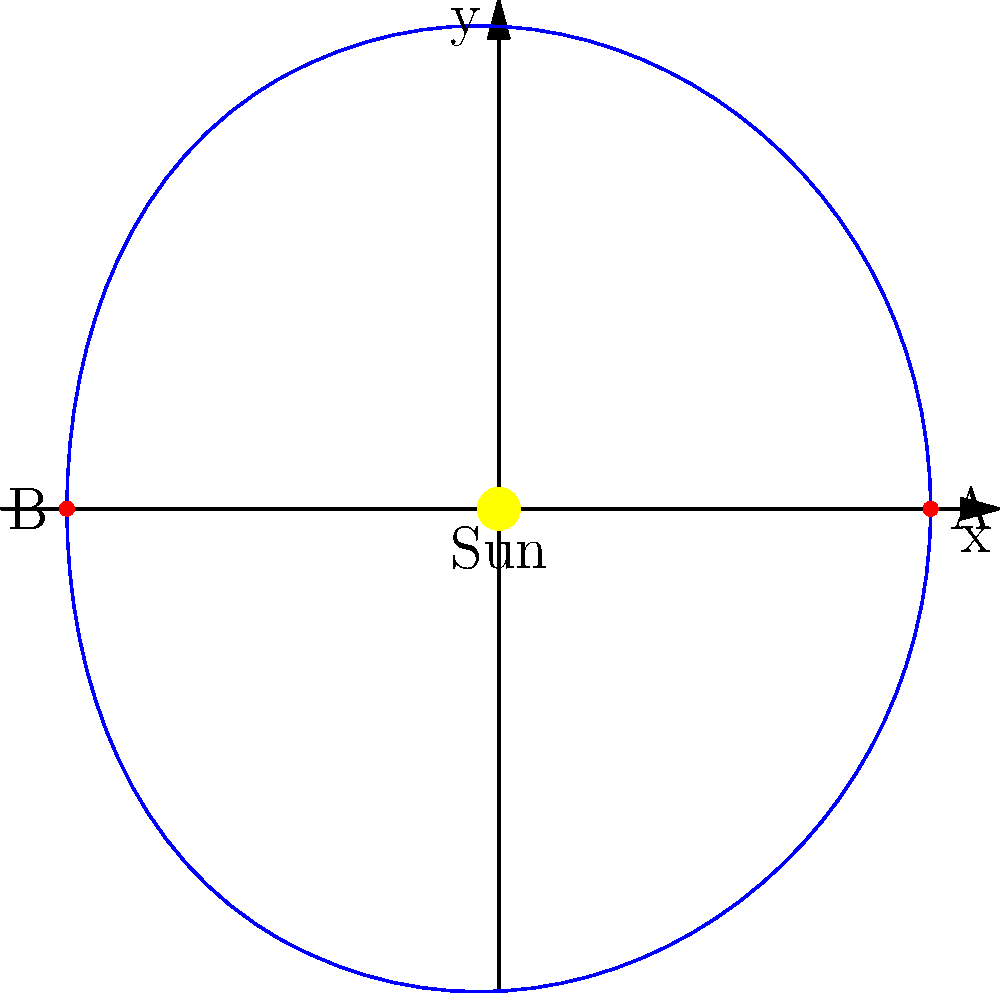In the diagram, a comet's elliptical orbit around the Sun is shown. The comet is at point A when closest to the Sun (perihelion) and at point B when farthest from the Sun (aphelion). At which point does the comet move faster, and why would this be particularly relevant for planning an advertising campaign for a space tourism company? To answer this question, we need to consider Kepler's laws of planetary motion, which also apply to comets:

1. Kepler's First Law: The orbit of a planet (or comet) around the Sun is an ellipse with the Sun at one of the two foci.

2. Kepler's Second Law: A line segment joining a planet (or comet) and the Sun sweeps out equal areas during equal intervals of time.

3. Kepler's Third Law: The square of the orbital period of a planet is directly proportional to the cube of the semi-major axis of its orbit.

For this question, Kepler's Second Law is most relevant. It implies that:

a) The comet's speed is not constant throughout its orbit.
b) The comet moves faster when it's closer to the Sun.
c) The comet moves slower when it's farther from the Sun.

Therefore, the comet moves faster at point A (perihelion) than at point B (aphelion).

For an advertising executive planning a campaign for a space tourism company, this information is crucial because:

1. Timing: The best time to view the comet would be when it's at or near perihelion (point A), as it would appear brighter and move faster across the sky, creating a more spectacular show for potential space tourists.

2. Marketing Strategy: The campaign could emphasize the unique opportunity to witness the comet at its fastest and brightest, creating a sense of urgency and exclusivity.

3. Product Development: The space tourism company could develop special "comet viewing" packages timed to coincide with the comet's perihelion passage.

4. Educational Content: The campaign could include educational elements about orbital mechanics, increasing interest and engagement among potential customers.

5. Long-term Planning: Understanding the comet's orbit allows for planning future viewing opportunities and marketing campaigns around its periodic returns.
Answer: Point A (perihelion); crucial for timing spectacular viewings and creating urgency in space tourism marketing. 